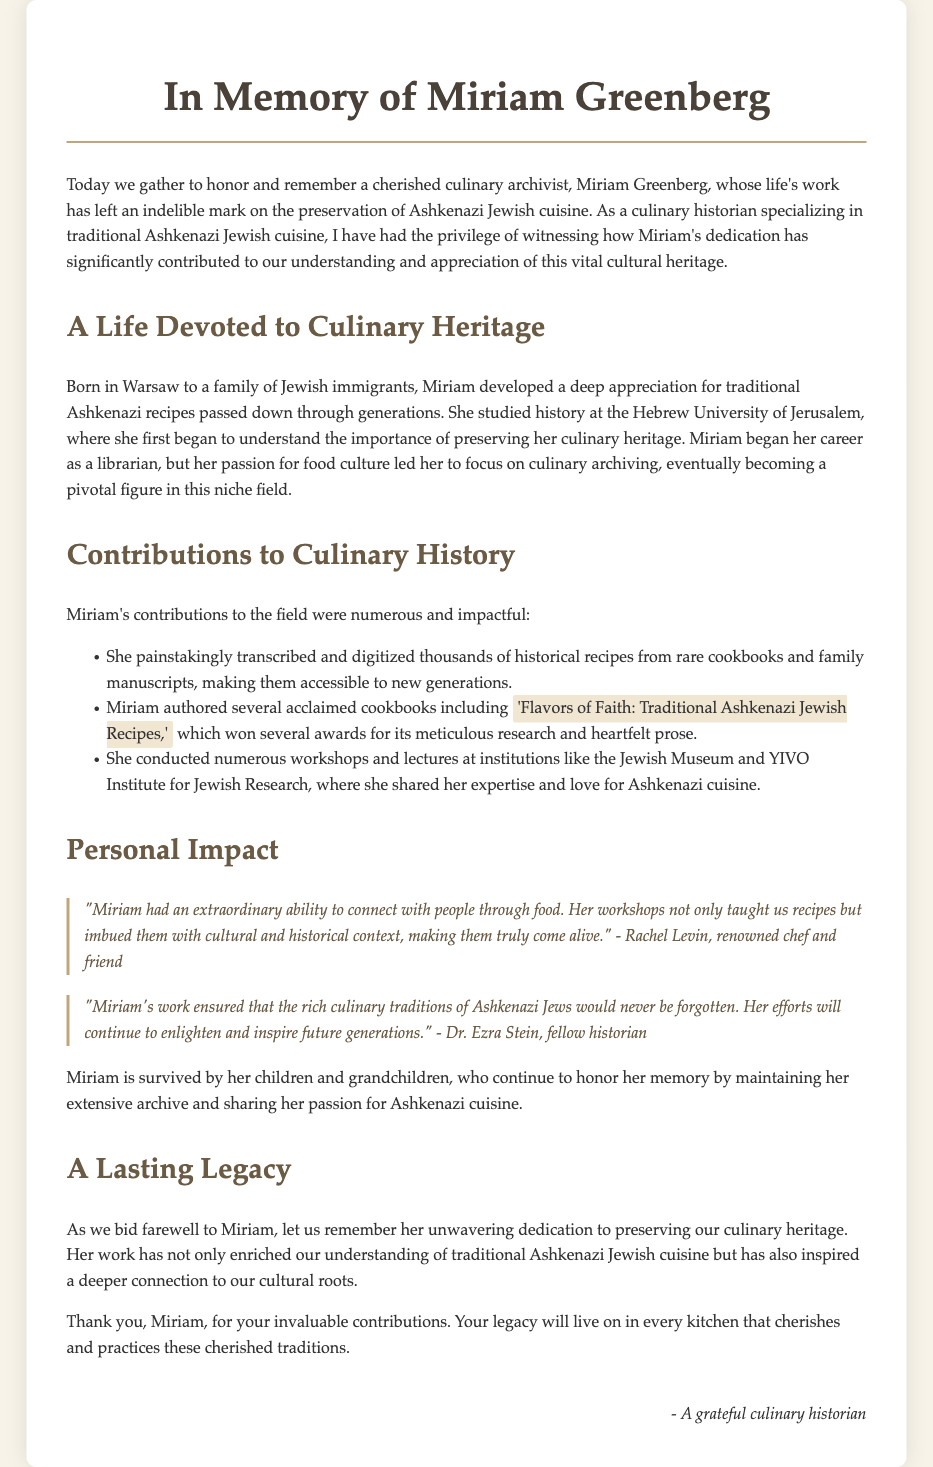What was Miriam Greenberg's profession? The document states that Miriam was a culinary archivist, focusing on preserving Ashkenazi Jewish cuisine.
Answer: Culinary archivist Where was Miriam born? The document mentions that Miriam was born in Warsaw.
Answer: Warsaw What is the title of one of Miriam's acclaimed cookbooks? The document lists the title of her cookbook as 'Flavors of Faith: Traditional Ashkenazi Jewish Recipes.'
Answer: Flavors of Faith: Traditional Ashkenazi Jewish Recipes Which institution did Miriam conduct workshops at? The document references her workshops at the Jewish Museum and YIVO Institute for Jewish Research.
Answer: Jewish Museum and YIVO Institute for Jewish Research What ability did Miriam have that is highlighted by Rachel Levin? Rachel Levin highlights Miriam's extraordinary ability to connect with people through food.
Answer: Connect with people through food How many children and grandchildren did Miriam leave behind? The document mentions that Miriam is survived by her children and grandchildren, though it does not provide a specific number.
Answer: Children and grandchildren What did Dr. Ezra Stein state about Miriam's work? Dr. Ezra Stein noted that her work ensured the culinary traditions of Ashkenazi Jews would not be forgotten.
Answer: Not be forgotten What are attendees encouraged to remember about Miriam? The eulogy encourages attendees to remember her unwavering dedication to preserving culinary heritage.
Answer: Unwavering dedication to preserving culinary heritage In what city did Miriam study history? The document mentions that she studied history at the Hebrew University of Jerusalem.
Answer: Hebrew University of Jerusalem 